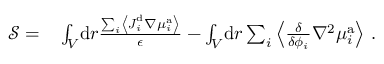<formula> <loc_0><loc_0><loc_500><loc_500>\begin{array} { r l } { \mathcal { S } = } & \int _ { V } \, d r \frac { \sum _ { i } \left \langle J _ { i } ^ { d } \nabla { \mu } _ { i } ^ { a } \right \rangle } { \epsilon } - \int _ { V } \, d r \sum _ { i } \left \langle \frac { \delta } { \delta { \phi _ { i } } } \nabla ^ { 2 } \mu _ { i } ^ { a } \right \rangle \, . } \end{array}</formula> 